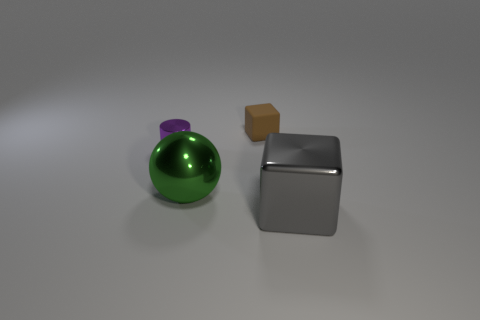What material is the purple thing that is the same size as the brown cube?
Your answer should be compact. Metal. Is there a small purple thing made of the same material as the large green thing?
Ensure brevity in your answer.  Yes. There is a purple metal cylinder that is in front of the cube behind the gray object; are there any objects left of it?
Your answer should be very brief. No. What shape is the gray metallic object that is the same size as the green sphere?
Provide a short and direct response. Cube. There is a cube behind the large gray block; does it have the same size as the object that is in front of the large green shiny sphere?
Provide a short and direct response. No. How many yellow matte cubes are there?
Provide a succinct answer. 0. There is a thing that is on the right side of the block that is behind the block that is in front of the brown object; what is its size?
Your response must be concise. Large. Does the small block have the same color as the big block?
Provide a succinct answer. No. Is there any other thing that is the same size as the cylinder?
Your response must be concise. Yes. What number of small purple metal cylinders are behind the green object?
Provide a short and direct response. 1. 